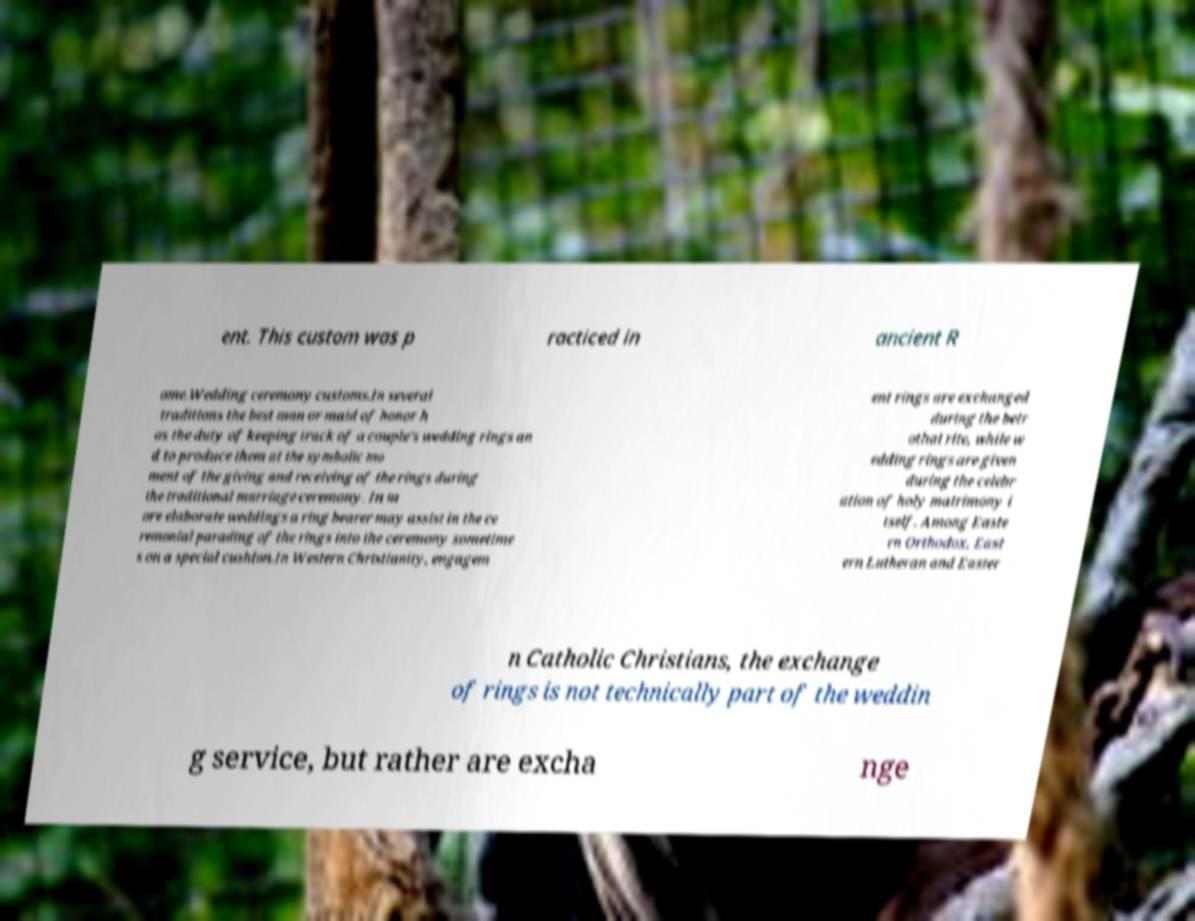Can you read and provide the text displayed in the image?This photo seems to have some interesting text. Can you extract and type it out for me? ent. This custom was p racticed in ancient R ome.Wedding ceremony customs.In several traditions the best man or maid of honor h as the duty of keeping track of a couple's wedding rings an d to produce them at the symbolic mo ment of the giving and receiving of the rings during the traditional marriage ceremony. In m ore elaborate weddings a ring bearer may assist in the ce remonial parading of the rings into the ceremony sometime s on a special cushion.In Western Christianity, engagem ent rings are exchanged during the betr othal rite, while w edding rings are given during the celebr ation of holy matrimony i tself. Among Easte rn Orthodox, East ern Lutheran and Easter n Catholic Christians, the exchange of rings is not technically part of the weddin g service, but rather are excha nge 